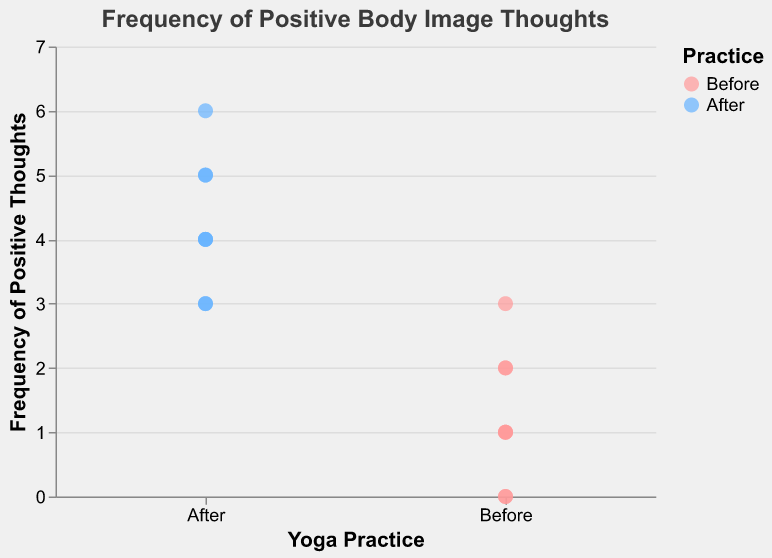What's the title of the figure? The title of the figure is displayed at the top of the plot.
Answer: Frequency of Positive Body Image Thoughts How many data points are there for 'Before' yoga practice? There are individual points for each "Before" data entry, count them visually in the category labeled 'Before'.
Answer: 7 Which category has the highest frequency of positive thoughts after yoga practice? Look at the 'After' category and find the highest value on the y-axis for points labeled 'After'.
Answer: Feeling centered What is the difference between the highest frequency of positive thoughts before and after yoga practice? Identify the highest point in each practice category and subtract the 'Before' value from the 'After' value.
Answer: 6 - 3 = 3 How does the color scheme differentiate the practices? Observe the legend and the color-coded points in the plot.
Answer: 'Before' is pink, 'After' is blue What is the average frequency of positive thoughts after yoga practice? Sum the frequencies of 'After' points and divide by the number of 'After' points.
Answer: (5+4+6+3+4+5+3+4)/8 = 4.25 Which thought corresponds to the lowest frequency before yoga? Find the 'Before' point with the lowest y-axis value and note the corresponding thought.
Answer: Negative self-talk or Feeling unfit Compare the frequencies of "Feeling more confident" and "Increased body awareness" after yoga practice. Which is higher? Look at the y-axis values for these thoughts in the 'After' category.
Answer: Feeling more confident (4 vs. 3) What does the y-axis represent? Check the y-axis label for information about what is being measured.
Answer: Frequency of Positive Thoughts How many unique thoughts are noted in the 'After' yoga practice category? Count the unique thought labels listed under the 'After' category.
Answer: 8 